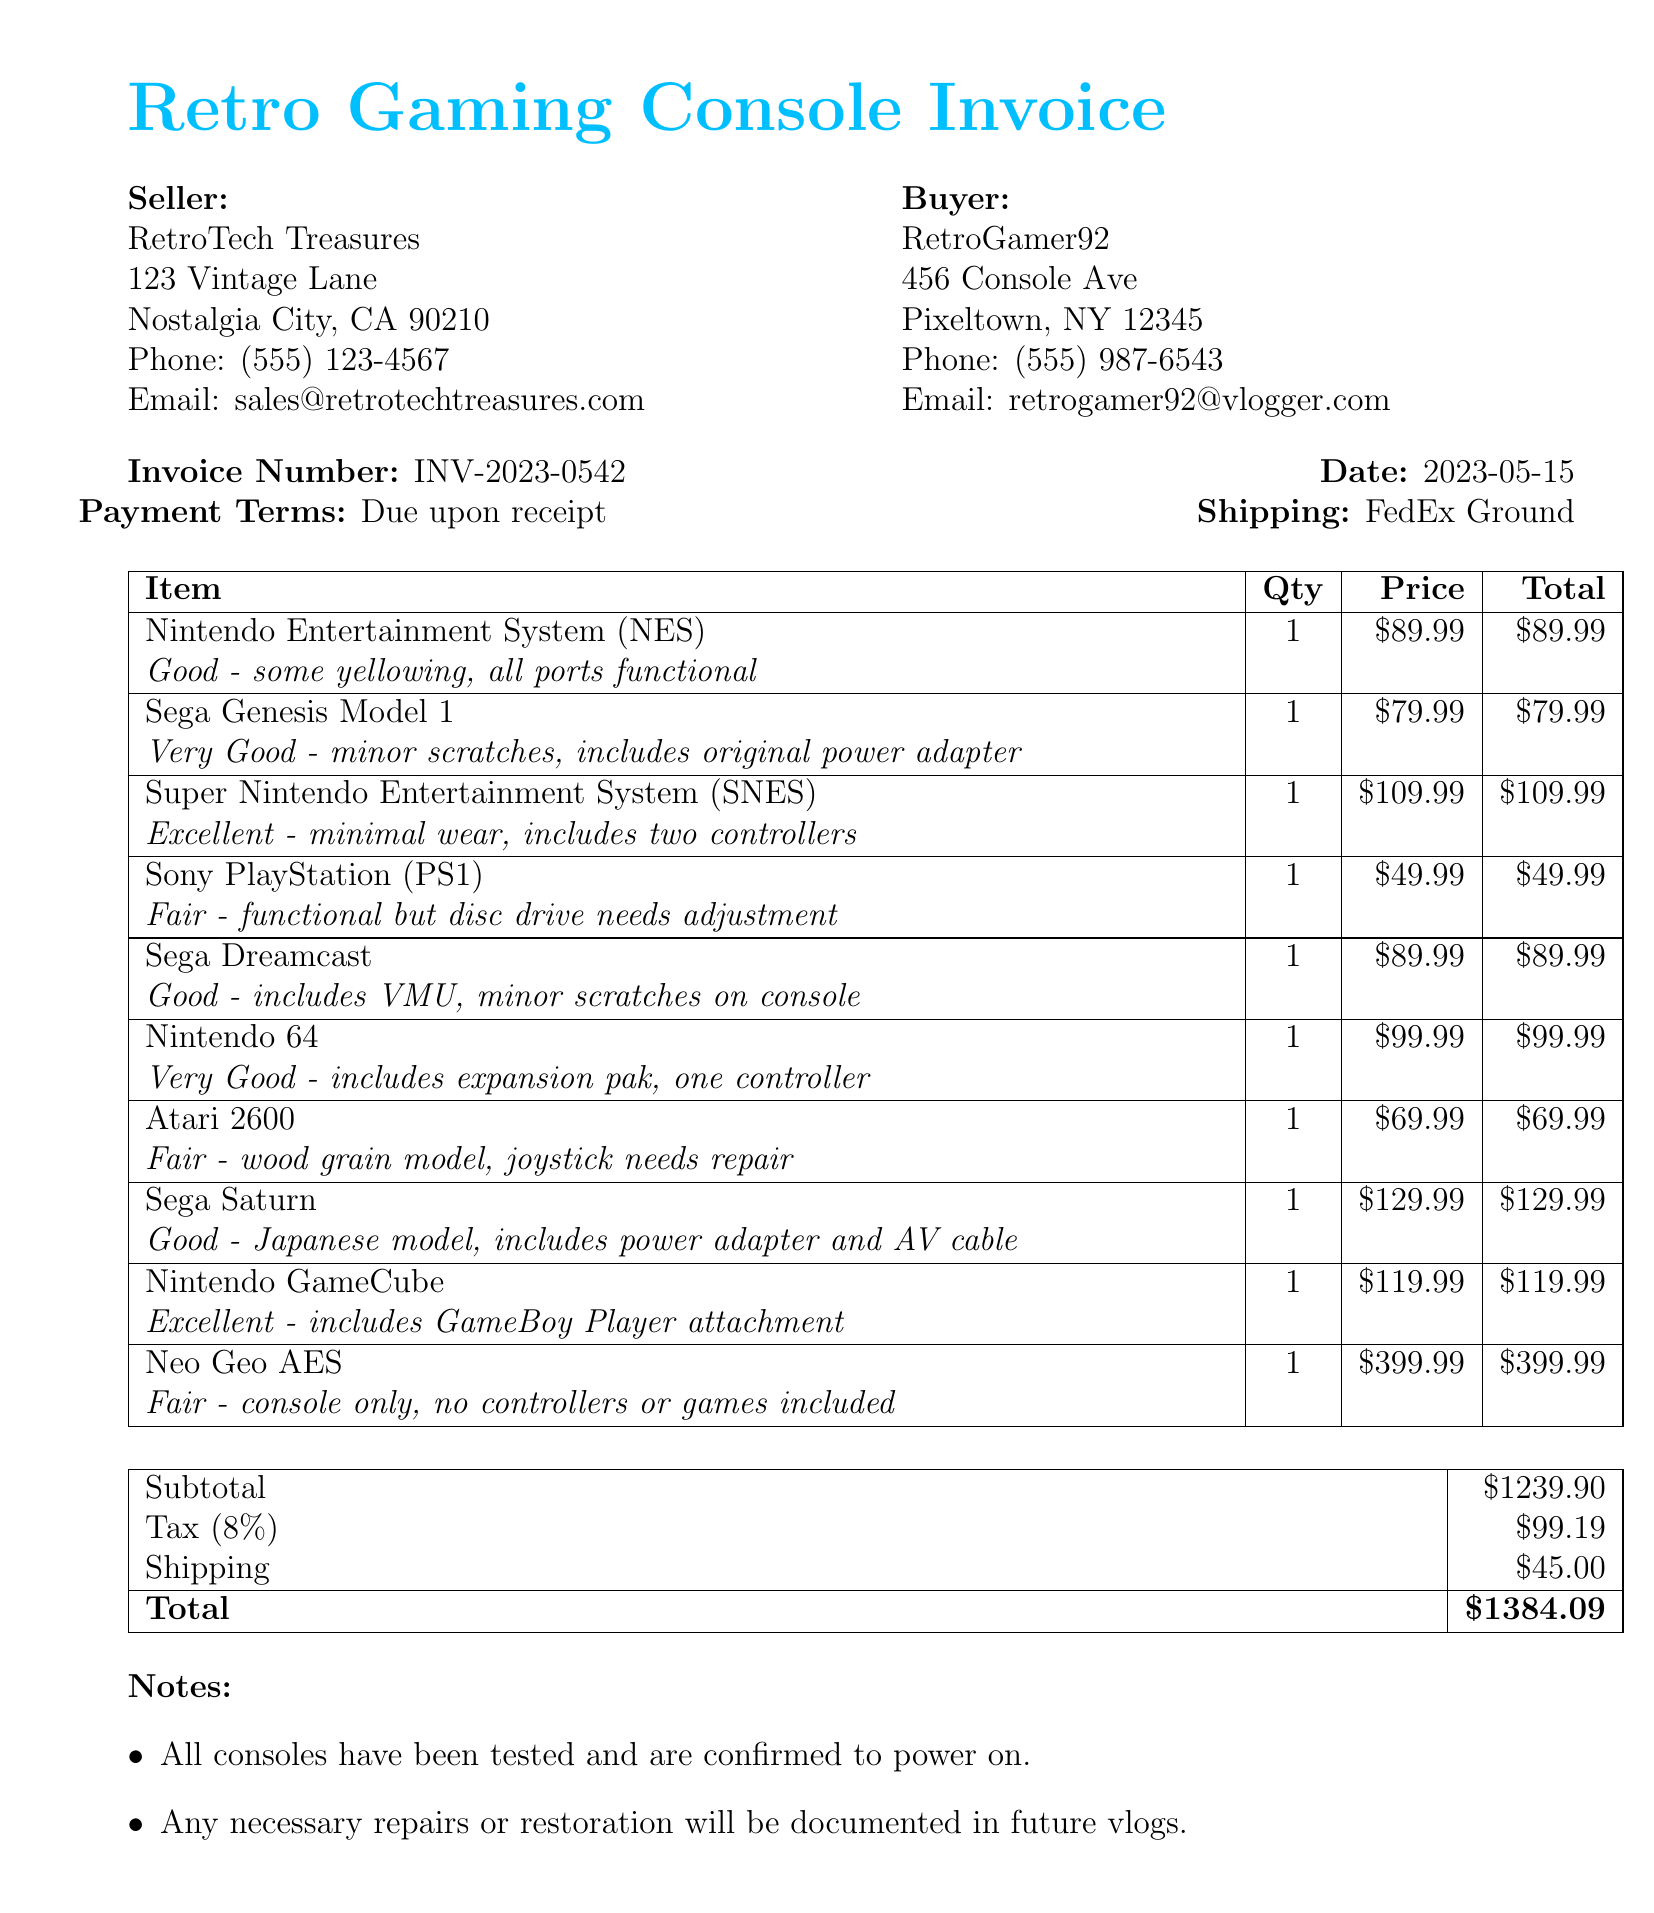What is the name of the seller? The name of the seller is listed in the document as RetroTech Treasures.
Answer: RetroTech Treasures What is the invoice number? The document specifies the invoice number as INV-2023-0542.
Answer: INV-2023-0542 What is the total amount due? The total amount due is calculated as $1239.90 (subtotal) + $99.19 (tax) + $45.00 (shipping), which totals to $1384.09.
Answer: $1384.09 How many items are listed for purchase? There are 10 items detailed in the itemized list of the document.
Answer: 10 What is the condition of the Sega Genesis Model 1? The condition details for the Sega Genesis Model 1 state it is in "Very Good - minor scratches, includes original power adapter".
Answer: Very Good - minor scratches, includes original power adapter What is the shipping method specified in the invoice? The document indicates that the shipping method is FedEx Ground.
Answer: FedEx Ground What is the tax rate applied to the invoice? The document lists the tax rate as 8%.
Answer: 8% What does the note about repairs say? The notes indicate that any necessary repairs or restoration will be documented in future vlogs.
Answer: Any necessary repairs or restoration will be documented in future vlogs 